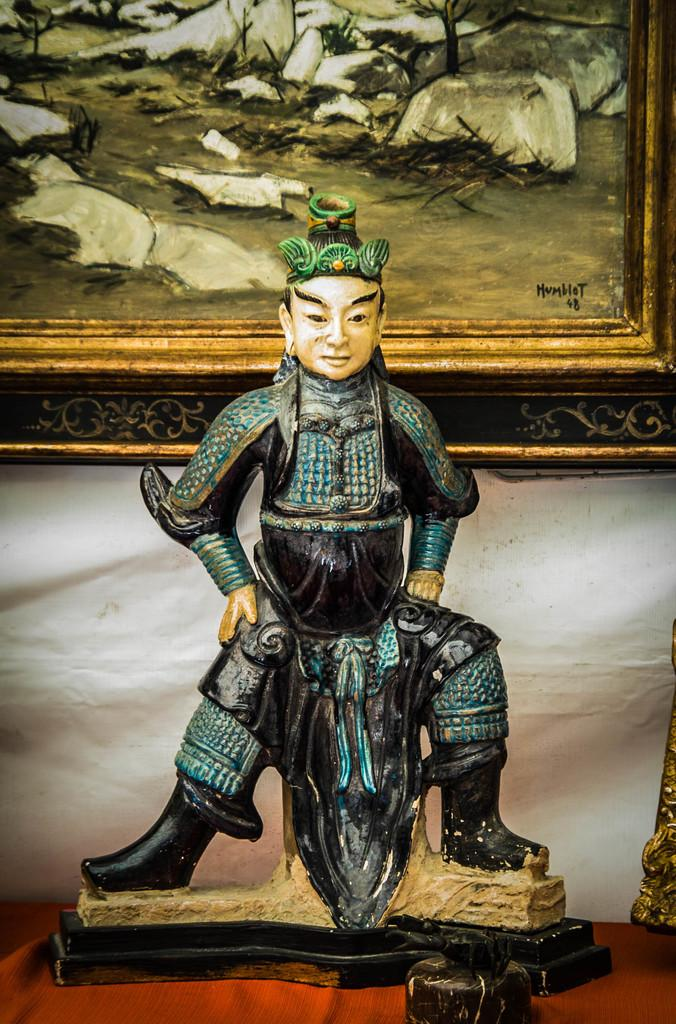What is the main subject of the image? There is a sculpture on a cloth in the image. What can be seen in the background of the image? There is a frame on the wall in the background of the image. Can you describe the object on the right side of the image? Unfortunately, the provided facts do not give enough information to describe the object on the right side of the image. What invention is being showcased by the star in the image? There is no star or invention present in the image. 